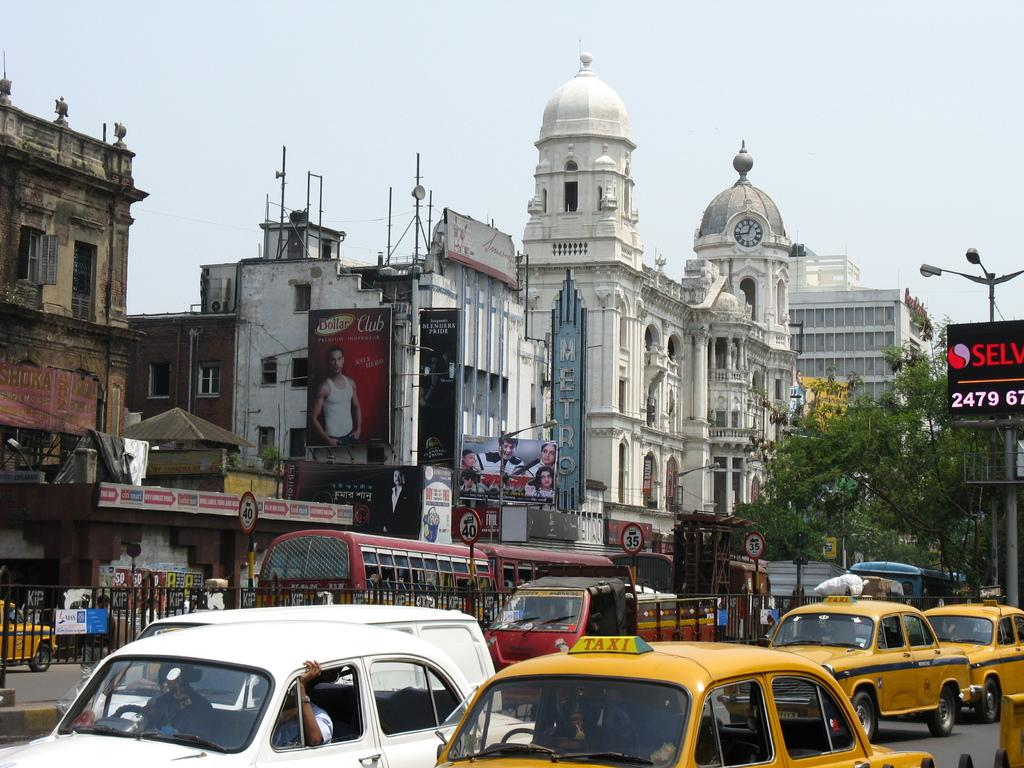<image>
Create a compact narrative representing the image presented. A city scene with an ad for Dollar club on the left. 